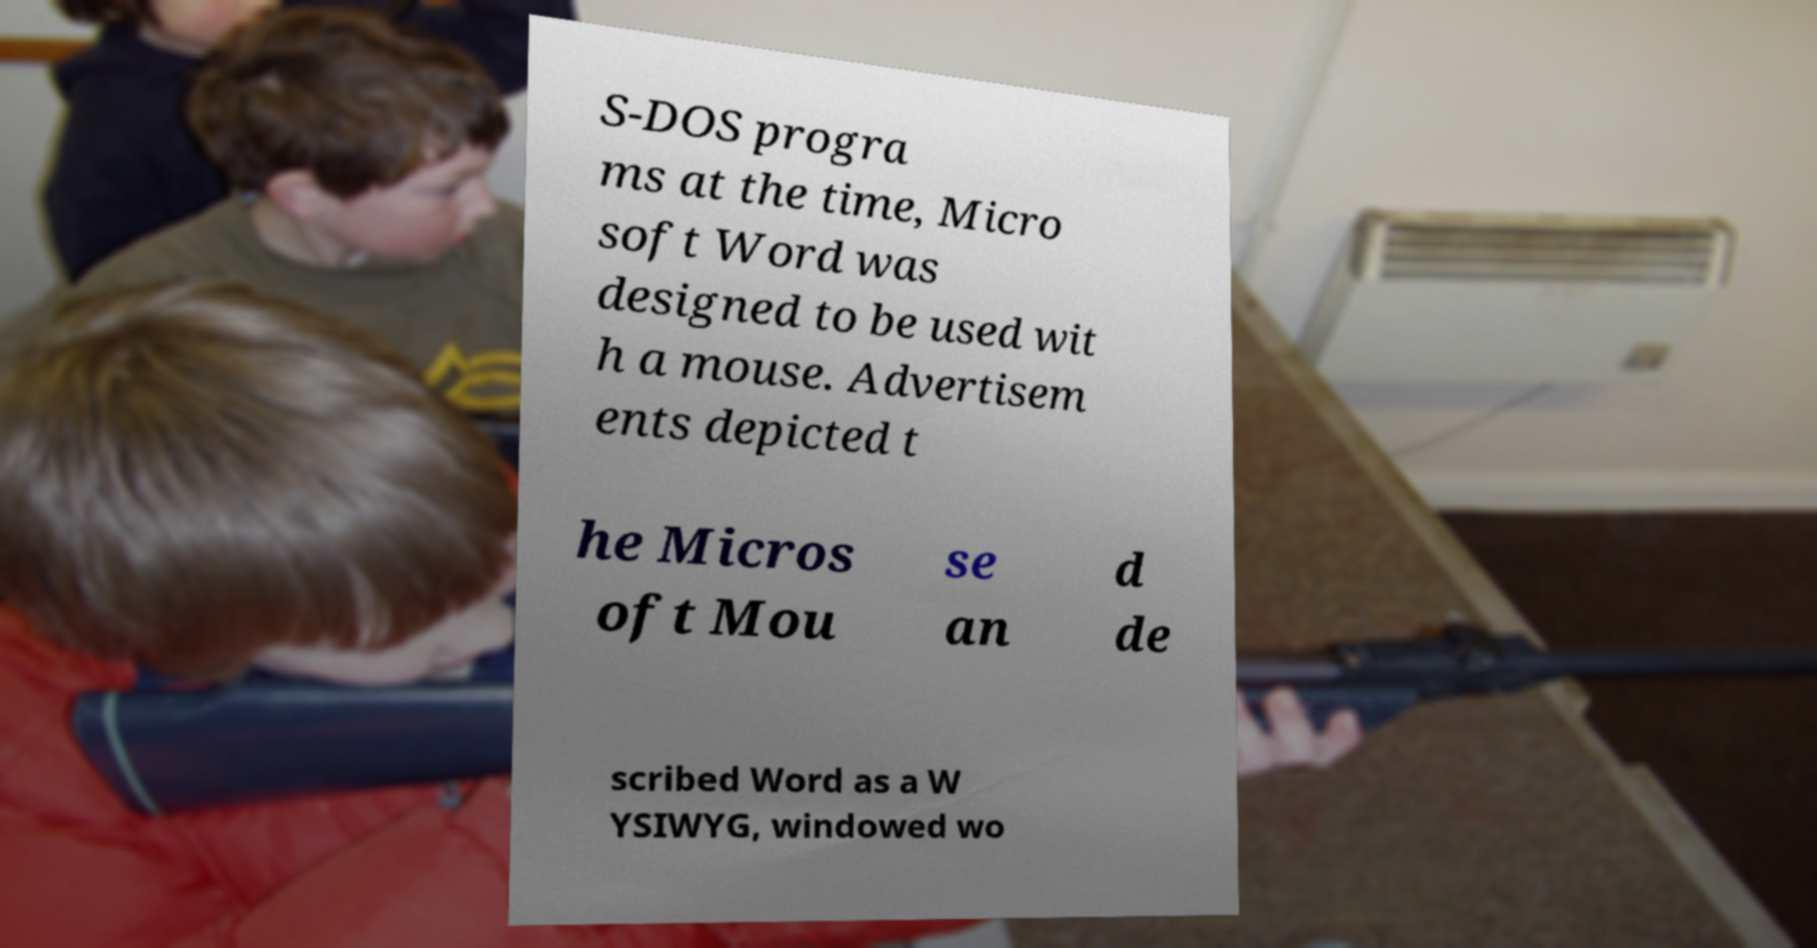For documentation purposes, I need the text within this image transcribed. Could you provide that? S-DOS progra ms at the time, Micro soft Word was designed to be used wit h a mouse. Advertisem ents depicted t he Micros oft Mou se an d de scribed Word as a W YSIWYG, windowed wo 